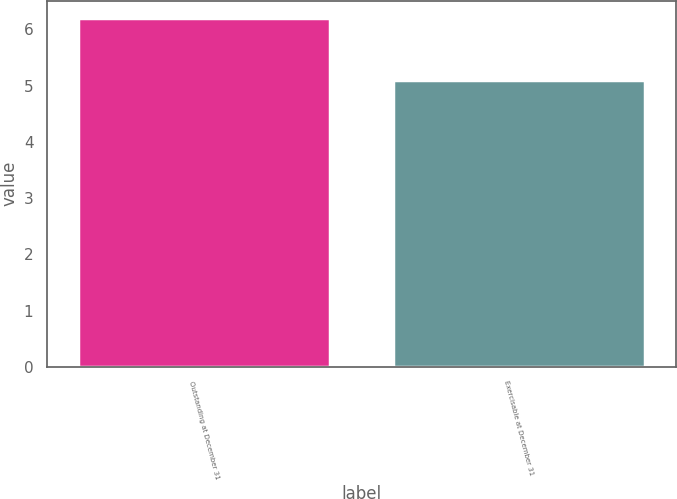Convert chart to OTSL. <chart><loc_0><loc_0><loc_500><loc_500><bar_chart><fcel>Outstanding at December 31<fcel>Exercisable at December 31<nl><fcel>6.2<fcel>5.1<nl></chart> 